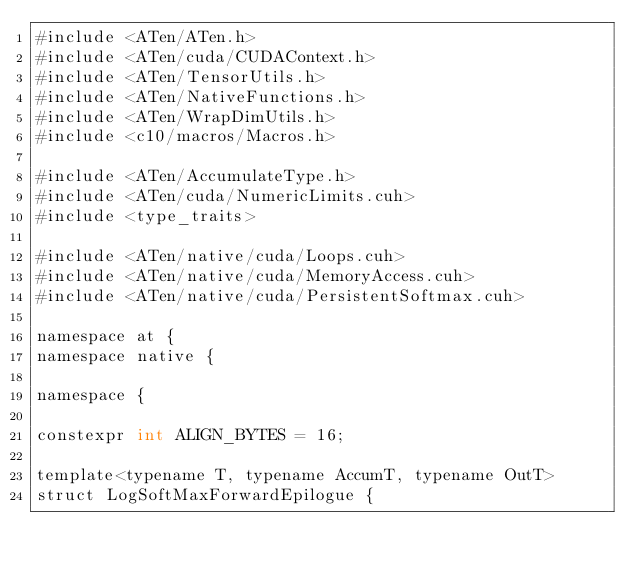<code> <loc_0><loc_0><loc_500><loc_500><_Cuda_>#include <ATen/ATen.h>
#include <ATen/cuda/CUDAContext.h>
#include <ATen/TensorUtils.h>
#include <ATen/NativeFunctions.h>
#include <ATen/WrapDimUtils.h>
#include <c10/macros/Macros.h>

#include <ATen/AccumulateType.h>
#include <ATen/cuda/NumericLimits.cuh>
#include <type_traits>

#include <ATen/native/cuda/Loops.cuh>
#include <ATen/native/cuda/MemoryAccess.cuh>
#include <ATen/native/cuda/PersistentSoftmax.cuh>

namespace at {
namespace native {

namespace {

constexpr int ALIGN_BYTES = 16;

template<typename T, typename AccumT, typename OutT>
struct LogSoftMaxForwardEpilogue {</code> 